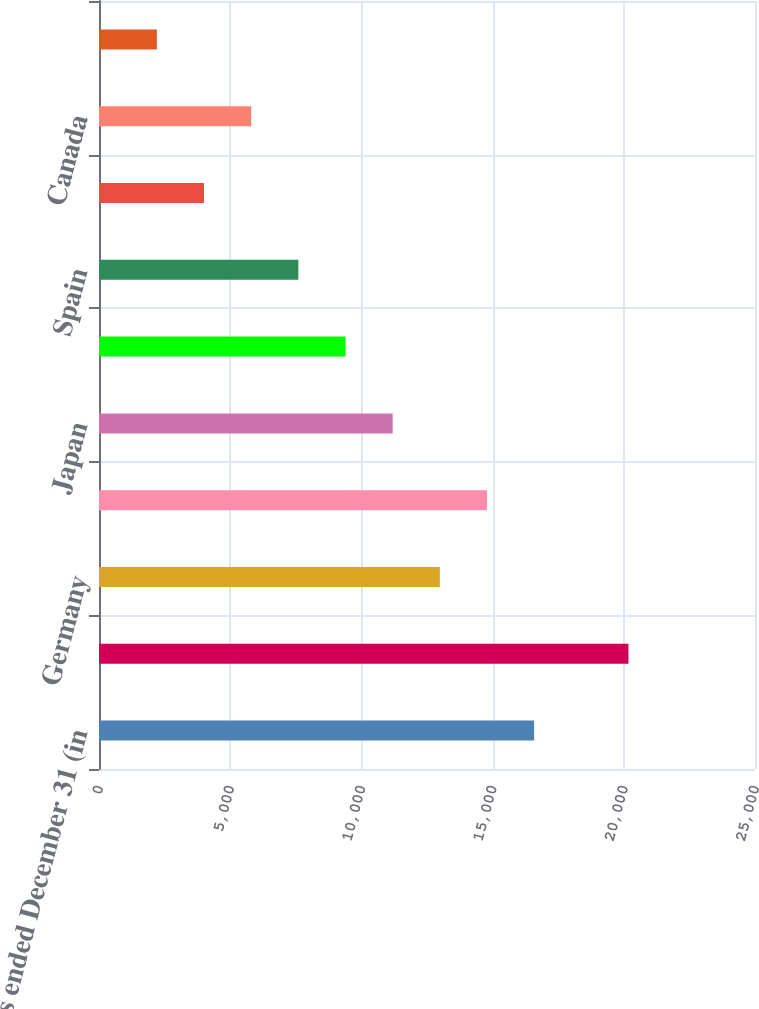Convert chart to OTSL. <chart><loc_0><loc_0><loc_500><loc_500><bar_chart><fcel>years ended December 31 (in<fcel>United States<fcel>Germany<fcel>The Netherlands<fcel>Japan<fcel>United Kingdom<fcel>Spain<fcel>France<fcel>Canada<fcel>Brazil<nl><fcel>16582.8<fcel>20177.2<fcel>12988.4<fcel>14785.6<fcel>11191.2<fcel>9394<fcel>7596.8<fcel>4002.4<fcel>5799.6<fcel>2205.2<nl></chart> 